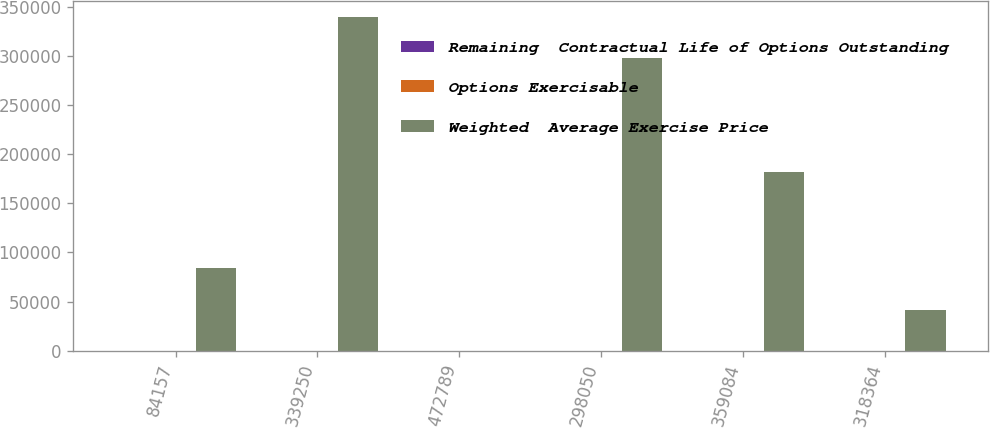Convert chart. <chart><loc_0><loc_0><loc_500><loc_500><stacked_bar_chart><ecel><fcel>84157<fcel>339250<fcel>472789<fcel>298050<fcel>359084<fcel>318364<nl><fcel>Remaining  Contractual Life of Options Outstanding<fcel>46.32<fcel>61.57<fcel>81.31<fcel>108.9<fcel>141.51<fcel>201.64<nl><fcel>Options Exercisable<fcel>1<fcel>2.8<fcel>5.3<fcel>3.9<fcel>7.3<fcel>9.3<nl><fcel>Weighted  Average Exercise Price<fcel>84157<fcel>339250<fcel>81.31<fcel>298050<fcel>181965<fcel>40928<nl></chart> 